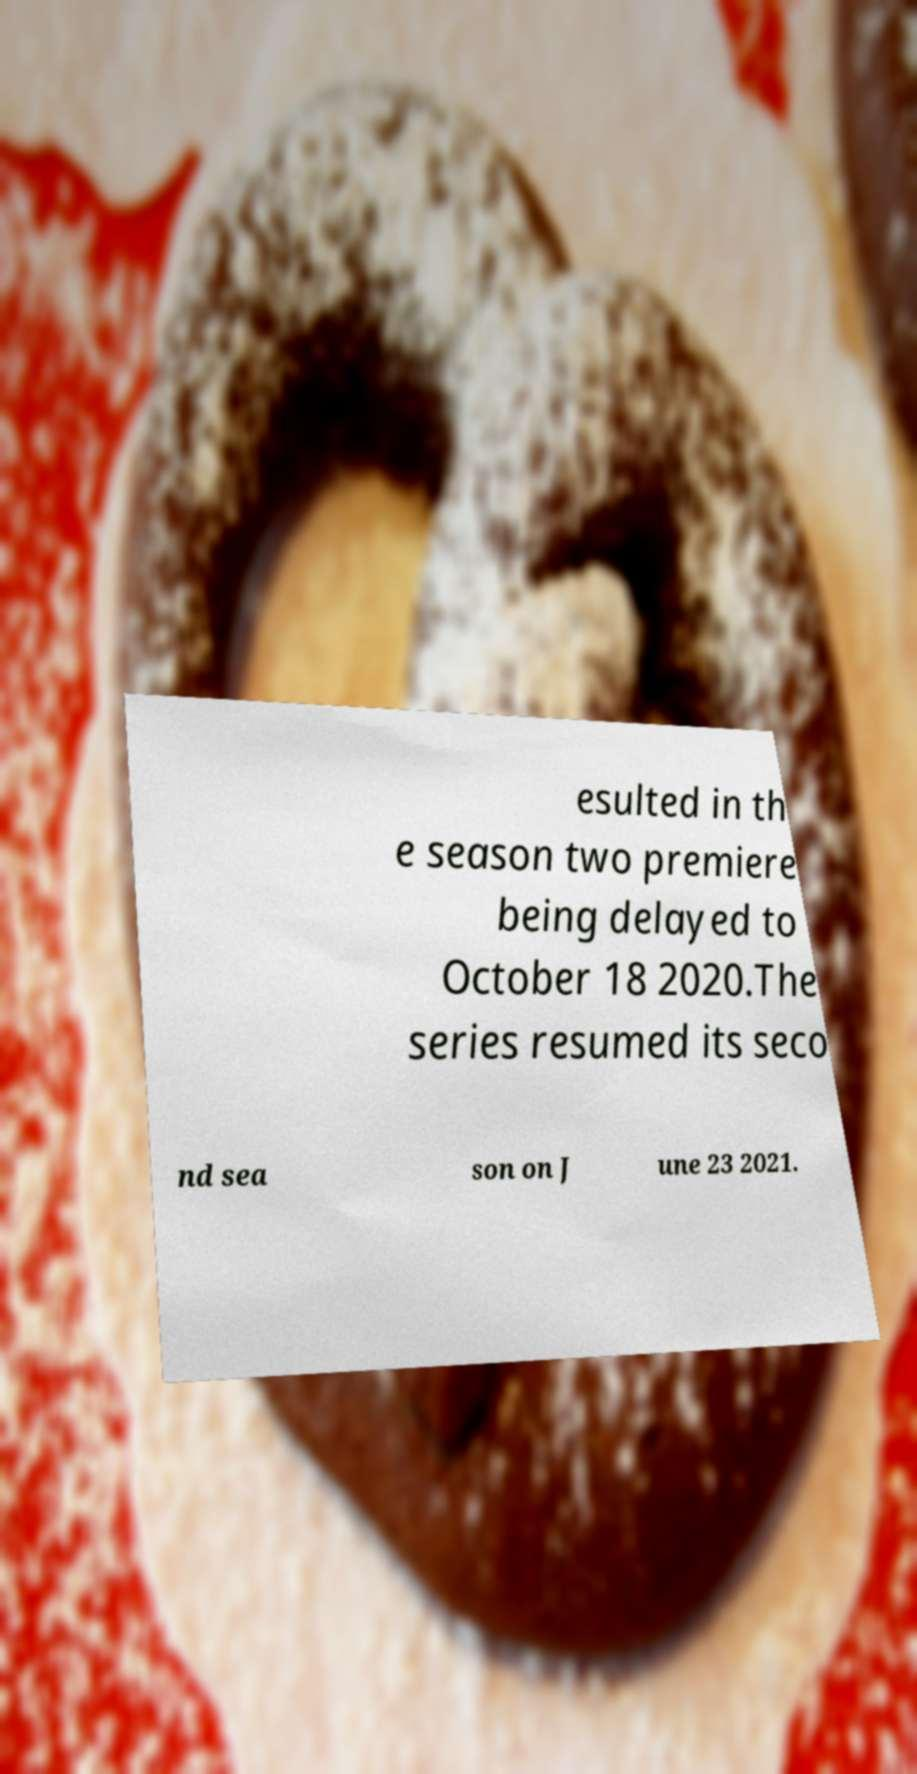Could you extract and type out the text from this image? esulted in th e season two premiere being delayed to October 18 2020.The series resumed its seco nd sea son on J une 23 2021. 